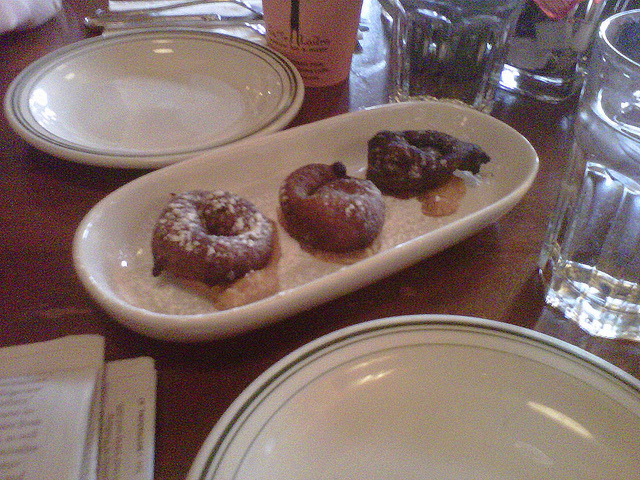How many donuts are there? 3 